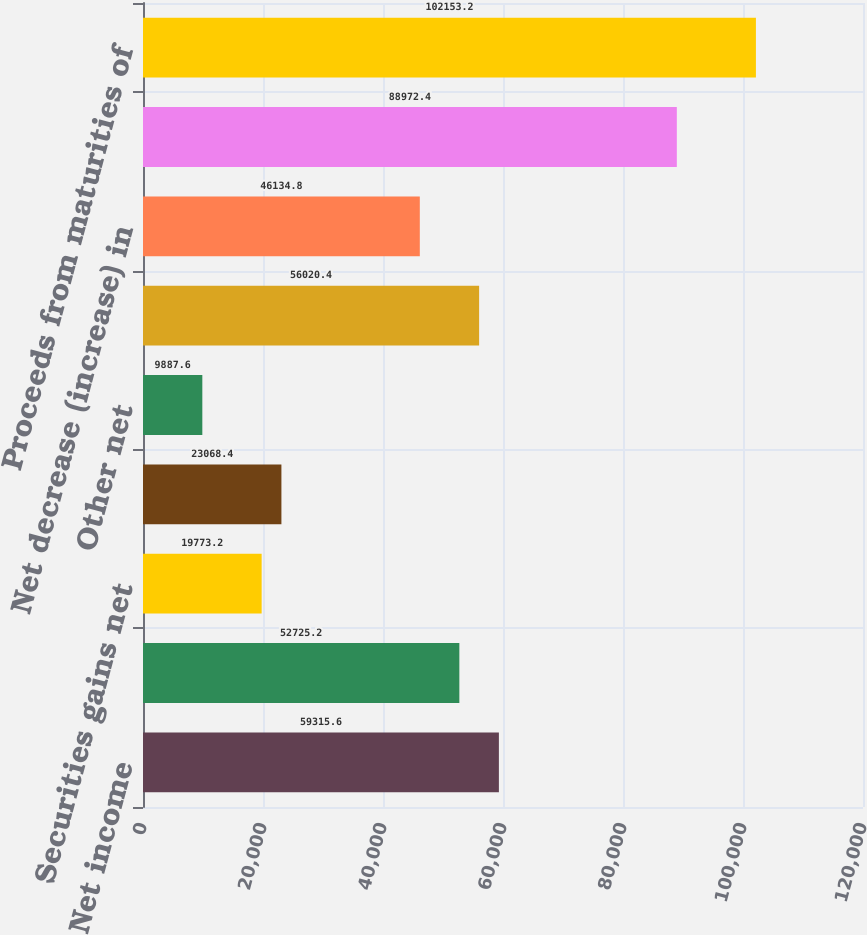Convert chart to OTSL. <chart><loc_0><loc_0><loc_500><loc_500><bar_chart><fcel>Net income<fcel>Non-cash charges for<fcel>Securities gains net<fcel>Change in trading account<fcel>Other net<fcel>Net Cash Provided by Operating<fcel>Net decrease (increase) in<fcel>Proceeds from sales of<fcel>Proceeds from maturities of<nl><fcel>59315.6<fcel>52725.2<fcel>19773.2<fcel>23068.4<fcel>9887.6<fcel>56020.4<fcel>46134.8<fcel>88972.4<fcel>102153<nl></chart> 